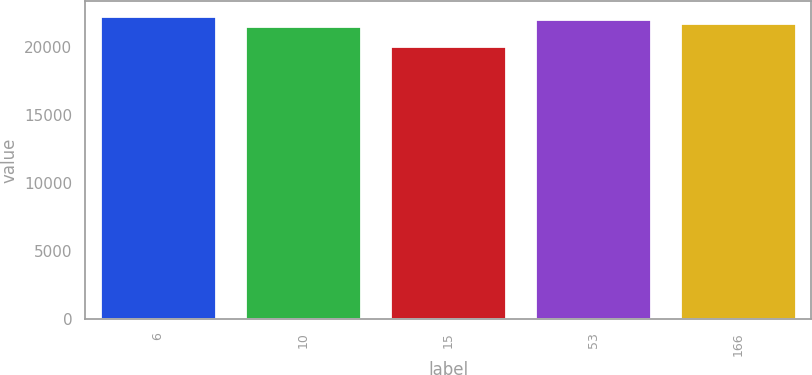Convert chart to OTSL. <chart><loc_0><loc_0><loc_500><loc_500><bar_chart><fcel>6<fcel>10<fcel>15<fcel>53<fcel>166<nl><fcel>22264.6<fcel>21548<fcel>20069<fcel>22055<fcel>21757.6<nl></chart> 